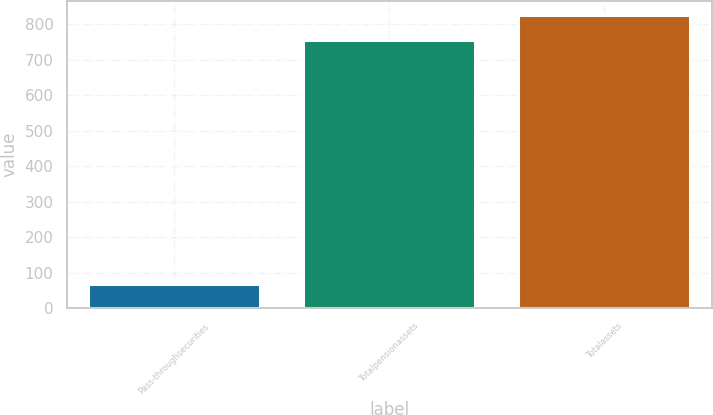Convert chart. <chart><loc_0><loc_0><loc_500><loc_500><bar_chart><fcel>Pass-throughsecurities<fcel>Totalpensionassets<fcel>Totalassets<nl><fcel>69<fcel>756<fcel>825.6<nl></chart> 